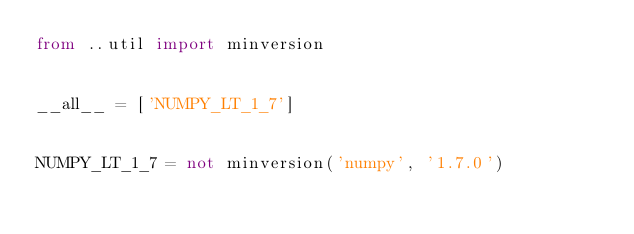<code> <loc_0><loc_0><loc_500><loc_500><_Python_>from ..util import minversion


__all__ = ['NUMPY_LT_1_7']


NUMPY_LT_1_7 = not minversion('numpy', '1.7.0')
</code> 